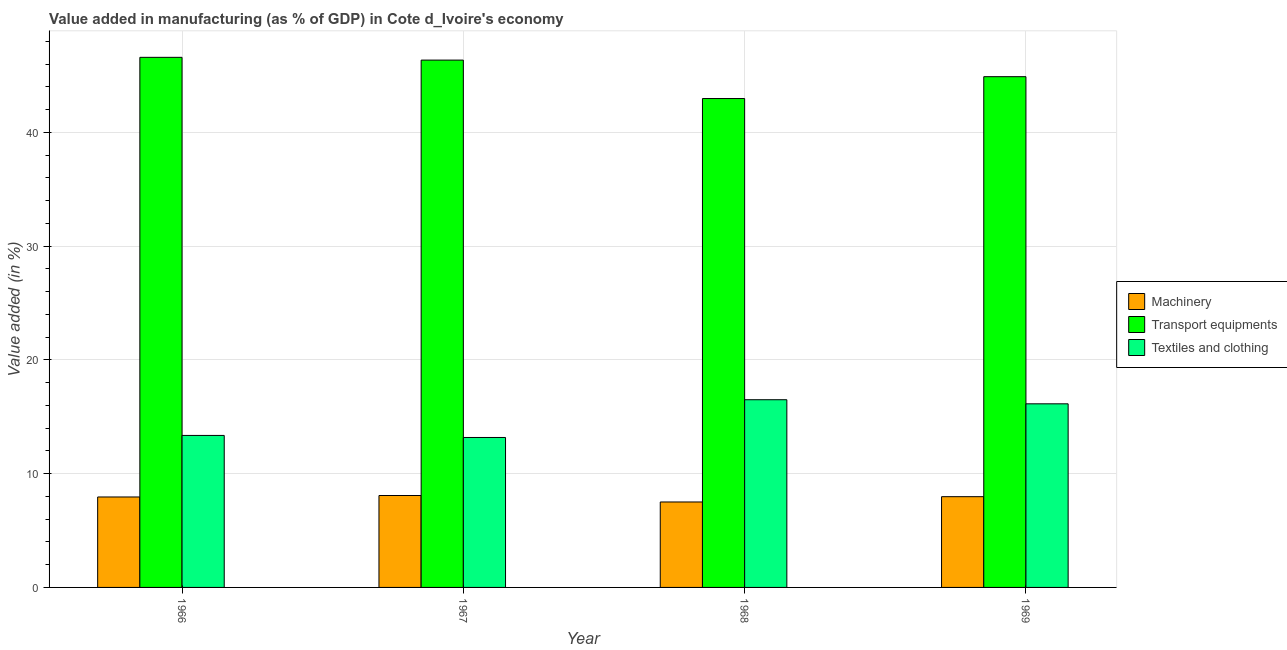How many different coloured bars are there?
Offer a terse response. 3. How many groups of bars are there?
Provide a succinct answer. 4. Are the number of bars per tick equal to the number of legend labels?
Give a very brief answer. Yes. Are the number of bars on each tick of the X-axis equal?
Make the answer very short. Yes. How many bars are there on the 1st tick from the right?
Keep it short and to the point. 3. What is the label of the 4th group of bars from the left?
Your response must be concise. 1969. What is the value added in manufacturing textile and clothing in 1968?
Keep it short and to the point. 16.5. Across all years, what is the maximum value added in manufacturing textile and clothing?
Provide a short and direct response. 16.5. Across all years, what is the minimum value added in manufacturing transport equipments?
Provide a short and direct response. 42.98. In which year was the value added in manufacturing transport equipments maximum?
Make the answer very short. 1966. In which year was the value added in manufacturing machinery minimum?
Offer a very short reply. 1968. What is the total value added in manufacturing transport equipments in the graph?
Provide a succinct answer. 180.84. What is the difference between the value added in manufacturing textile and clothing in 1967 and that in 1969?
Offer a very short reply. -2.96. What is the difference between the value added in manufacturing transport equipments in 1969 and the value added in manufacturing machinery in 1968?
Offer a terse response. 1.92. What is the average value added in manufacturing machinery per year?
Offer a terse response. 7.88. In the year 1968, what is the difference between the value added in manufacturing transport equipments and value added in manufacturing textile and clothing?
Offer a very short reply. 0. In how many years, is the value added in manufacturing transport equipments greater than 14 %?
Your answer should be compact. 4. What is the ratio of the value added in manufacturing textile and clothing in 1966 to that in 1969?
Your answer should be compact. 0.83. Is the difference between the value added in manufacturing textile and clothing in 1966 and 1967 greater than the difference between the value added in manufacturing machinery in 1966 and 1967?
Give a very brief answer. No. What is the difference between the highest and the second highest value added in manufacturing transport equipments?
Your response must be concise. 0.24. What is the difference between the highest and the lowest value added in manufacturing textile and clothing?
Provide a succinct answer. 3.32. Is the sum of the value added in manufacturing machinery in 1966 and 1968 greater than the maximum value added in manufacturing transport equipments across all years?
Offer a terse response. Yes. What does the 1st bar from the left in 1968 represents?
Give a very brief answer. Machinery. What does the 3rd bar from the right in 1969 represents?
Offer a terse response. Machinery. How many bars are there?
Make the answer very short. 12. Are the values on the major ticks of Y-axis written in scientific E-notation?
Make the answer very short. No. How many legend labels are there?
Offer a very short reply. 3. How are the legend labels stacked?
Offer a very short reply. Vertical. What is the title of the graph?
Your answer should be very brief. Value added in manufacturing (as % of GDP) in Cote d_Ivoire's economy. What is the label or title of the X-axis?
Offer a terse response. Year. What is the label or title of the Y-axis?
Keep it short and to the point. Value added (in %). What is the Value added (in %) in Machinery in 1966?
Provide a short and direct response. 7.95. What is the Value added (in %) of Transport equipments in 1966?
Your response must be concise. 46.6. What is the Value added (in %) of Textiles and clothing in 1966?
Keep it short and to the point. 13.36. What is the Value added (in %) in Machinery in 1967?
Make the answer very short. 8.08. What is the Value added (in %) in Transport equipments in 1967?
Your response must be concise. 46.36. What is the Value added (in %) of Textiles and clothing in 1967?
Keep it short and to the point. 13.18. What is the Value added (in %) in Machinery in 1968?
Offer a very short reply. 7.51. What is the Value added (in %) in Transport equipments in 1968?
Make the answer very short. 42.98. What is the Value added (in %) of Textiles and clothing in 1968?
Provide a succinct answer. 16.5. What is the Value added (in %) of Machinery in 1969?
Offer a very short reply. 7.98. What is the Value added (in %) in Transport equipments in 1969?
Offer a very short reply. 44.9. What is the Value added (in %) in Textiles and clothing in 1969?
Provide a short and direct response. 16.14. Across all years, what is the maximum Value added (in %) of Machinery?
Give a very brief answer. 8.08. Across all years, what is the maximum Value added (in %) of Transport equipments?
Give a very brief answer. 46.6. Across all years, what is the maximum Value added (in %) in Textiles and clothing?
Your response must be concise. 16.5. Across all years, what is the minimum Value added (in %) of Machinery?
Your response must be concise. 7.51. Across all years, what is the minimum Value added (in %) in Transport equipments?
Provide a succinct answer. 42.98. Across all years, what is the minimum Value added (in %) of Textiles and clothing?
Give a very brief answer. 13.18. What is the total Value added (in %) of Machinery in the graph?
Provide a succinct answer. 31.52. What is the total Value added (in %) in Transport equipments in the graph?
Provide a succinct answer. 180.84. What is the total Value added (in %) in Textiles and clothing in the graph?
Give a very brief answer. 59.18. What is the difference between the Value added (in %) of Machinery in 1966 and that in 1967?
Make the answer very short. -0.13. What is the difference between the Value added (in %) of Transport equipments in 1966 and that in 1967?
Your answer should be compact. 0.24. What is the difference between the Value added (in %) of Textiles and clothing in 1966 and that in 1967?
Keep it short and to the point. 0.18. What is the difference between the Value added (in %) of Machinery in 1966 and that in 1968?
Keep it short and to the point. 0.44. What is the difference between the Value added (in %) of Transport equipments in 1966 and that in 1968?
Ensure brevity in your answer.  3.62. What is the difference between the Value added (in %) of Textiles and clothing in 1966 and that in 1968?
Provide a short and direct response. -3.14. What is the difference between the Value added (in %) in Machinery in 1966 and that in 1969?
Offer a very short reply. -0.03. What is the difference between the Value added (in %) in Transport equipments in 1966 and that in 1969?
Offer a very short reply. 1.7. What is the difference between the Value added (in %) of Textiles and clothing in 1966 and that in 1969?
Your response must be concise. -2.78. What is the difference between the Value added (in %) in Machinery in 1967 and that in 1968?
Your answer should be very brief. 0.57. What is the difference between the Value added (in %) of Transport equipments in 1967 and that in 1968?
Provide a short and direct response. 3.38. What is the difference between the Value added (in %) in Textiles and clothing in 1967 and that in 1968?
Provide a succinct answer. -3.32. What is the difference between the Value added (in %) in Machinery in 1967 and that in 1969?
Your response must be concise. 0.1. What is the difference between the Value added (in %) of Transport equipments in 1967 and that in 1969?
Ensure brevity in your answer.  1.46. What is the difference between the Value added (in %) of Textiles and clothing in 1967 and that in 1969?
Provide a succinct answer. -2.96. What is the difference between the Value added (in %) in Machinery in 1968 and that in 1969?
Offer a terse response. -0.47. What is the difference between the Value added (in %) of Transport equipments in 1968 and that in 1969?
Your answer should be compact. -1.92. What is the difference between the Value added (in %) of Textiles and clothing in 1968 and that in 1969?
Your response must be concise. 0.36. What is the difference between the Value added (in %) in Machinery in 1966 and the Value added (in %) in Transport equipments in 1967?
Offer a very short reply. -38.41. What is the difference between the Value added (in %) in Machinery in 1966 and the Value added (in %) in Textiles and clothing in 1967?
Give a very brief answer. -5.23. What is the difference between the Value added (in %) in Transport equipments in 1966 and the Value added (in %) in Textiles and clothing in 1967?
Offer a terse response. 33.42. What is the difference between the Value added (in %) of Machinery in 1966 and the Value added (in %) of Transport equipments in 1968?
Your answer should be compact. -35.03. What is the difference between the Value added (in %) in Machinery in 1966 and the Value added (in %) in Textiles and clothing in 1968?
Ensure brevity in your answer.  -8.55. What is the difference between the Value added (in %) of Transport equipments in 1966 and the Value added (in %) of Textiles and clothing in 1968?
Your answer should be very brief. 30.1. What is the difference between the Value added (in %) of Machinery in 1966 and the Value added (in %) of Transport equipments in 1969?
Your response must be concise. -36.95. What is the difference between the Value added (in %) of Machinery in 1966 and the Value added (in %) of Textiles and clothing in 1969?
Make the answer very short. -8.19. What is the difference between the Value added (in %) of Transport equipments in 1966 and the Value added (in %) of Textiles and clothing in 1969?
Ensure brevity in your answer.  30.46. What is the difference between the Value added (in %) in Machinery in 1967 and the Value added (in %) in Transport equipments in 1968?
Provide a succinct answer. -34.9. What is the difference between the Value added (in %) in Machinery in 1967 and the Value added (in %) in Textiles and clothing in 1968?
Provide a short and direct response. -8.42. What is the difference between the Value added (in %) in Transport equipments in 1967 and the Value added (in %) in Textiles and clothing in 1968?
Your answer should be very brief. 29.86. What is the difference between the Value added (in %) of Machinery in 1967 and the Value added (in %) of Transport equipments in 1969?
Offer a terse response. -36.82. What is the difference between the Value added (in %) in Machinery in 1967 and the Value added (in %) in Textiles and clothing in 1969?
Your response must be concise. -8.06. What is the difference between the Value added (in %) of Transport equipments in 1967 and the Value added (in %) of Textiles and clothing in 1969?
Your response must be concise. 30.22. What is the difference between the Value added (in %) of Machinery in 1968 and the Value added (in %) of Transport equipments in 1969?
Your answer should be compact. -37.39. What is the difference between the Value added (in %) in Machinery in 1968 and the Value added (in %) in Textiles and clothing in 1969?
Keep it short and to the point. -8.63. What is the difference between the Value added (in %) of Transport equipments in 1968 and the Value added (in %) of Textiles and clothing in 1969?
Keep it short and to the point. 26.84. What is the average Value added (in %) of Machinery per year?
Provide a succinct answer. 7.88. What is the average Value added (in %) in Transport equipments per year?
Keep it short and to the point. 45.21. What is the average Value added (in %) in Textiles and clothing per year?
Keep it short and to the point. 14.8. In the year 1966, what is the difference between the Value added (in %) in Machinery and Value added (in %) in Transport equipments?
Your answer should be compact. -38.65. In the year 1966, what is the difference between the Value added (in %) in Machinery and Value added (in %) in Textiles and clothing?
Your answer should be very brief. -5.41. In the year 1966, what is the difference between the Value added (in %) in Transport equipments and Value added (in %) in Textiles and clothing?
Provide a short and direct response. 33.24. In the year 1967, what is the difference between the Value added (in %) of Machinery and Value added (in %) of Transport equipments?
Offer a terse response. -38.28. In the year 1967, what is the difference between the Value added (in %) of Machinery and Value added (in %) of Textiles and clothing?
Give a very brief answer. -5.1. In the year 1967, what is the difference between the Value added (in %) of Transport equipments and Value added (in %) of Textiles and clothing?
Provide a succinct answer. 33.18. In the year 1968, what is the difference between the Value added (in %) of Machinery and Value added (in %) of Transport equipments?
Your answer should be compact. -35.47. In the year 1968, what is the difference between the Value added (in %) in Machinery and Value added (in %) in Textiles and clothing?
Your response must be concise. -8.99. In the year 1968, what is the difference between the Value added (in %) in Transport equipments and Value added (in %) in Textiles and clothing?
Your answer should be very brief. 26.48. In the year 1969, what is the difference between the Value added (in %) in Machinery and Value added (in %) in Transport equipments?
Make the answer very short. -36.92. In the year 1969, what is the difference between the Value added (in %) of Machinery and Value added (in %) of Textiles and clothing?
Provide a short and direct response. -8.16. In the year 1969, what is the difference between the Value added (in %) in Transport equipments and Value added (in %) in Textiles and clothing?
Offer a terse response. 28.76. What is the ratio of the Value added (in %) of Machinery in 1966 to that in 1967?
Give a very brief answer. 0.98. What is the ratio of the Value added (in %) in Transport equipments in 1966 to that in 1967?
Keep it short and to the point. 1.01. What is the ratio of the Value added (in %) of Textiles and clothing in 1966 to that in 1967?
Make the answer very short. 1.01. What is the ratio of the Value added (in %) in Machinery in 1966 to that in 1968?
Your response must be concise. 1.06. What is the ratio of the Value added (in %) in Transport equipments in 1966 to that in 1968?
Give a very brief answer. 1.08. What is the ratio of the Value added (in %) in Textiles and clothing in 1966 to that in 1968?
Provide a succinct answer. 0.81. What is the ratio of the Value added (in %) of Transport equipments in 1966 to that in 1969?
Offer a terse response. 1.04. What is the ratio of the Value added (in %) of Textiles and clothing in 1966 to that in 1969?
Ensure brevity in your answer.  0.83. What is the ratio of the Value added (in %) of Machinery in 1967 to that in 1968?
Give a very brief answer. 1.08. What is the ratio of the Value added (in %) of Transport equipments in 1967 to that in 1968?
Give a very brief answer. 1.08. What is the ratio of the Value added (in %) in Textiles and clothing in 1967 to that in 1968?
Your answer should be compact. 0.8. What is the ratio of the Value added (in %) in Machinery in 1967 to that in 1969?
Keep it short and to the point. 1.01. What is the ratio of the Value added (in %) of Transport equipments in 1967 to that in 1969?
Keep it short and to the point. 1.03. What is the ratio of the Value added (in %) in Textiles and clothing in 1967 to that in 1969?
Ensure brevity in your answer.  0.82. What is the ratio of the Value added (in %) of Machinery in 1968 to that in 1969?
Your answer should be very brief. 0.94. What is the ratio of the Value added (in %) of Transport equipments in 1968 to that in 1969?
Your answer should be very brief. 0.96. What is the ratio of the Value added (in %) in Textiles and clothing in 1968 to that in 1969?
Provide a short and direct response. 1.02. What is the difference between the highest and the second highest Value added (in %) in Machinery?
Make the answer very short. 0.1. What is the difference between the highest and the second highest Value added (in %) of Transport equipments?
Your answer should be compact. 0.24. What is the difference between the highest and the second highest Value added (in %) of Textiles and clothing?
Provide a short and direct response. 0.36. What is the difference between the highest and the lowest Value added (in %) in Machinery?
Your answer should be compact. 0.57. What is the difference between the highest and the lowest Value added (in %) in Transport equipments?
Your answer should be compact. 3.62. What is the difference between the highest and the lowest Value added (in %) of Textiles and clothing?
Your response must be concise. 3.32. 